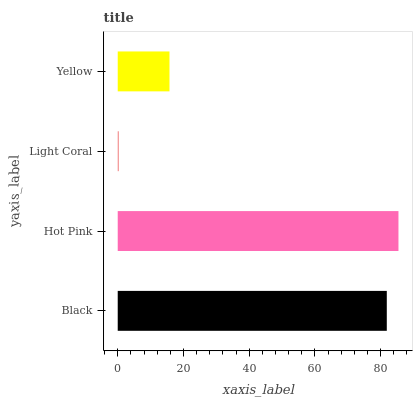Is Light Coral the minimum?
Answer yes or no. Yes. Is Hot Pink the maximum?
Answer yes or no. Yes. Is Hot Pink the minimum?
Answer yes or no. No. Is Light Coral the maximum?
Answer yes or no. No. Is Hot Pink greater than Light Coral?
Answer yes or no. Yes. Is Light Coral less than Hot Pink?
Answer yes or no. Yes. Is Light Coral greater than Hot Pink?
Answer yes or no. No. Is Hot Pink less than Light Coral?
Answer yes or no. No. Is Black the high median?
Answer yes or no. Yes. Is Yellow the low median?
Answer yes or no. Yes. Is Light Coral the high median?
Answer yes or no. No. Is Black the low median?
Answer yes or no. No. 